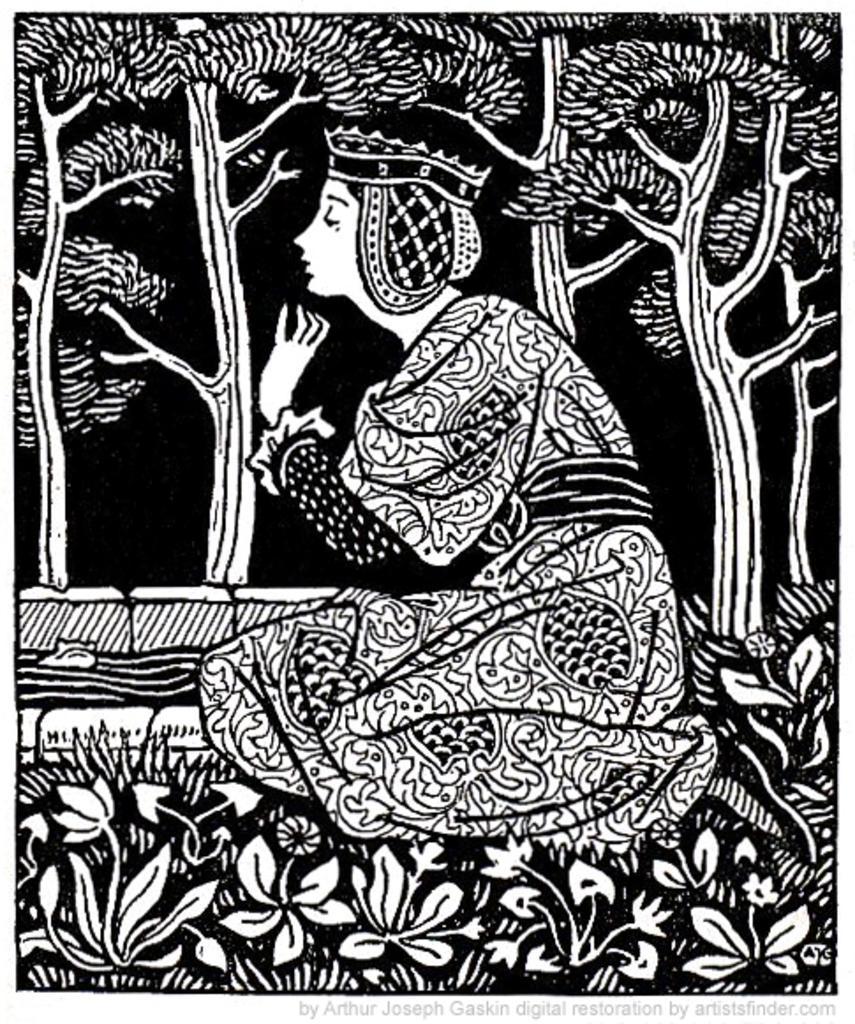Can you describe this image briefly? In this image I can see it is a sketch of a woman sitting. There are plants at the bottom, at the back side there are trees. 